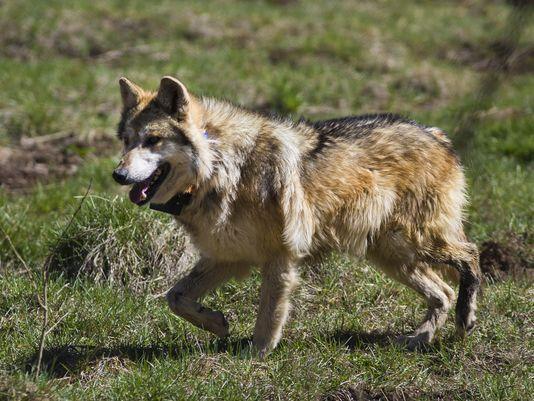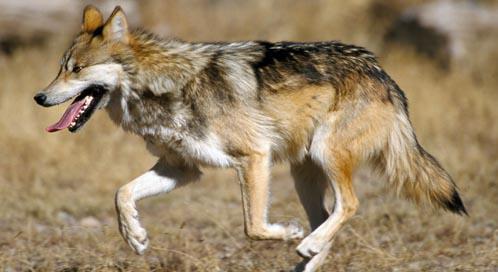The first image is the image on the left, the second image is the image on the right. Given the left and right images, does the statement "The wolf in one of the images is standing in the green grass." hold true? Answer yes or no. Yes. The first image is the image on the left, the second image is the image on the right. Assess this claim about the two images: "One image shows a leftward-facing wolf standing in a green grassy area.". Correct or not? Answer yes or no. Yes. 